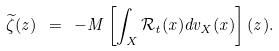Convert formula to latex. <formula><loc_0><loc_0><loc_500><loc_500>\widetilde { \zeta } ( z ) \ = \ - M \left [ \int _ { X } \mathcal { R } _ { t } ( x ) d v _ { X } ( x ) \right ] ( z ) .</formula> 